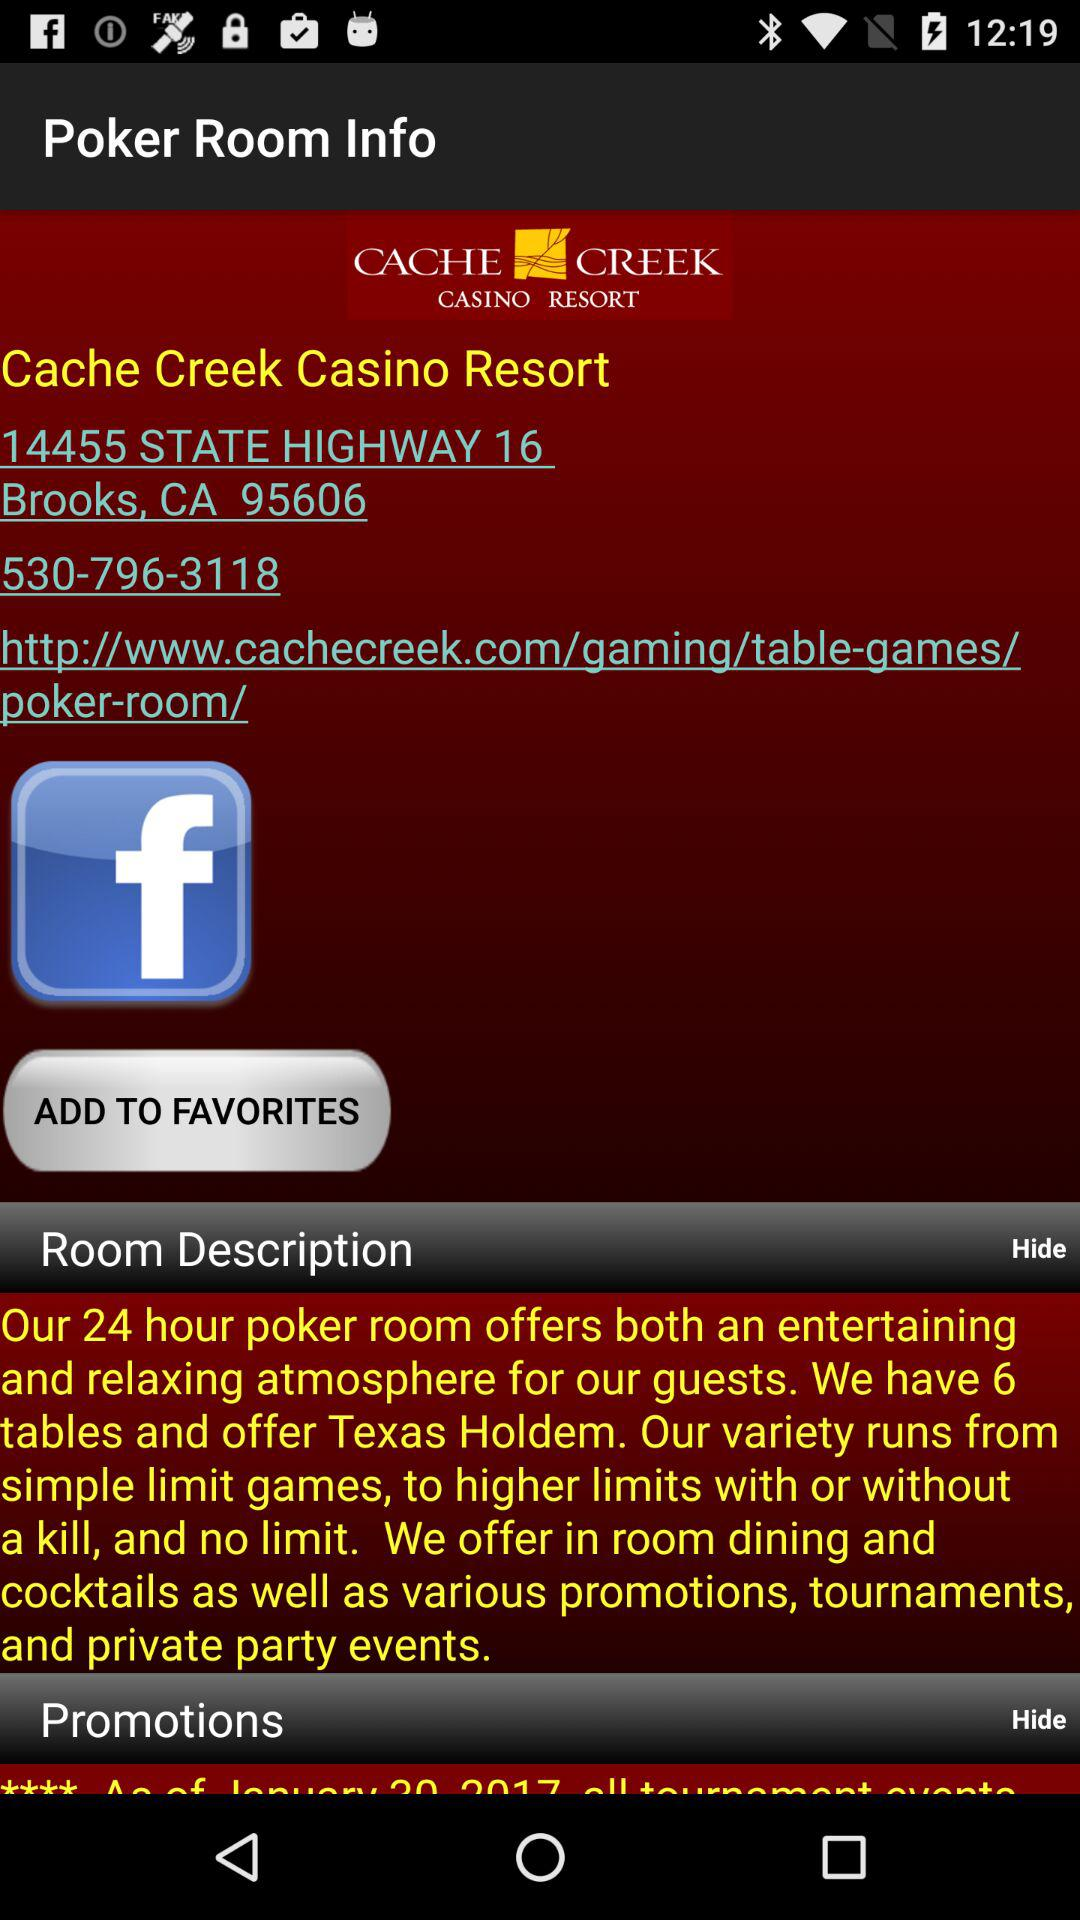What's the room description?
Answer the question using a single word or phrase. The room description is "Our 24 hour poker room offers both an entertaining and relaxing atmosphere for our guests. We have 6 tables and offer Texas Holdem. Our variety runs from simple limit games, to higher limits with or without a kill, and no limit. We offer in room dining and cocktails as well as various promotions, tournaments, and private party events." 